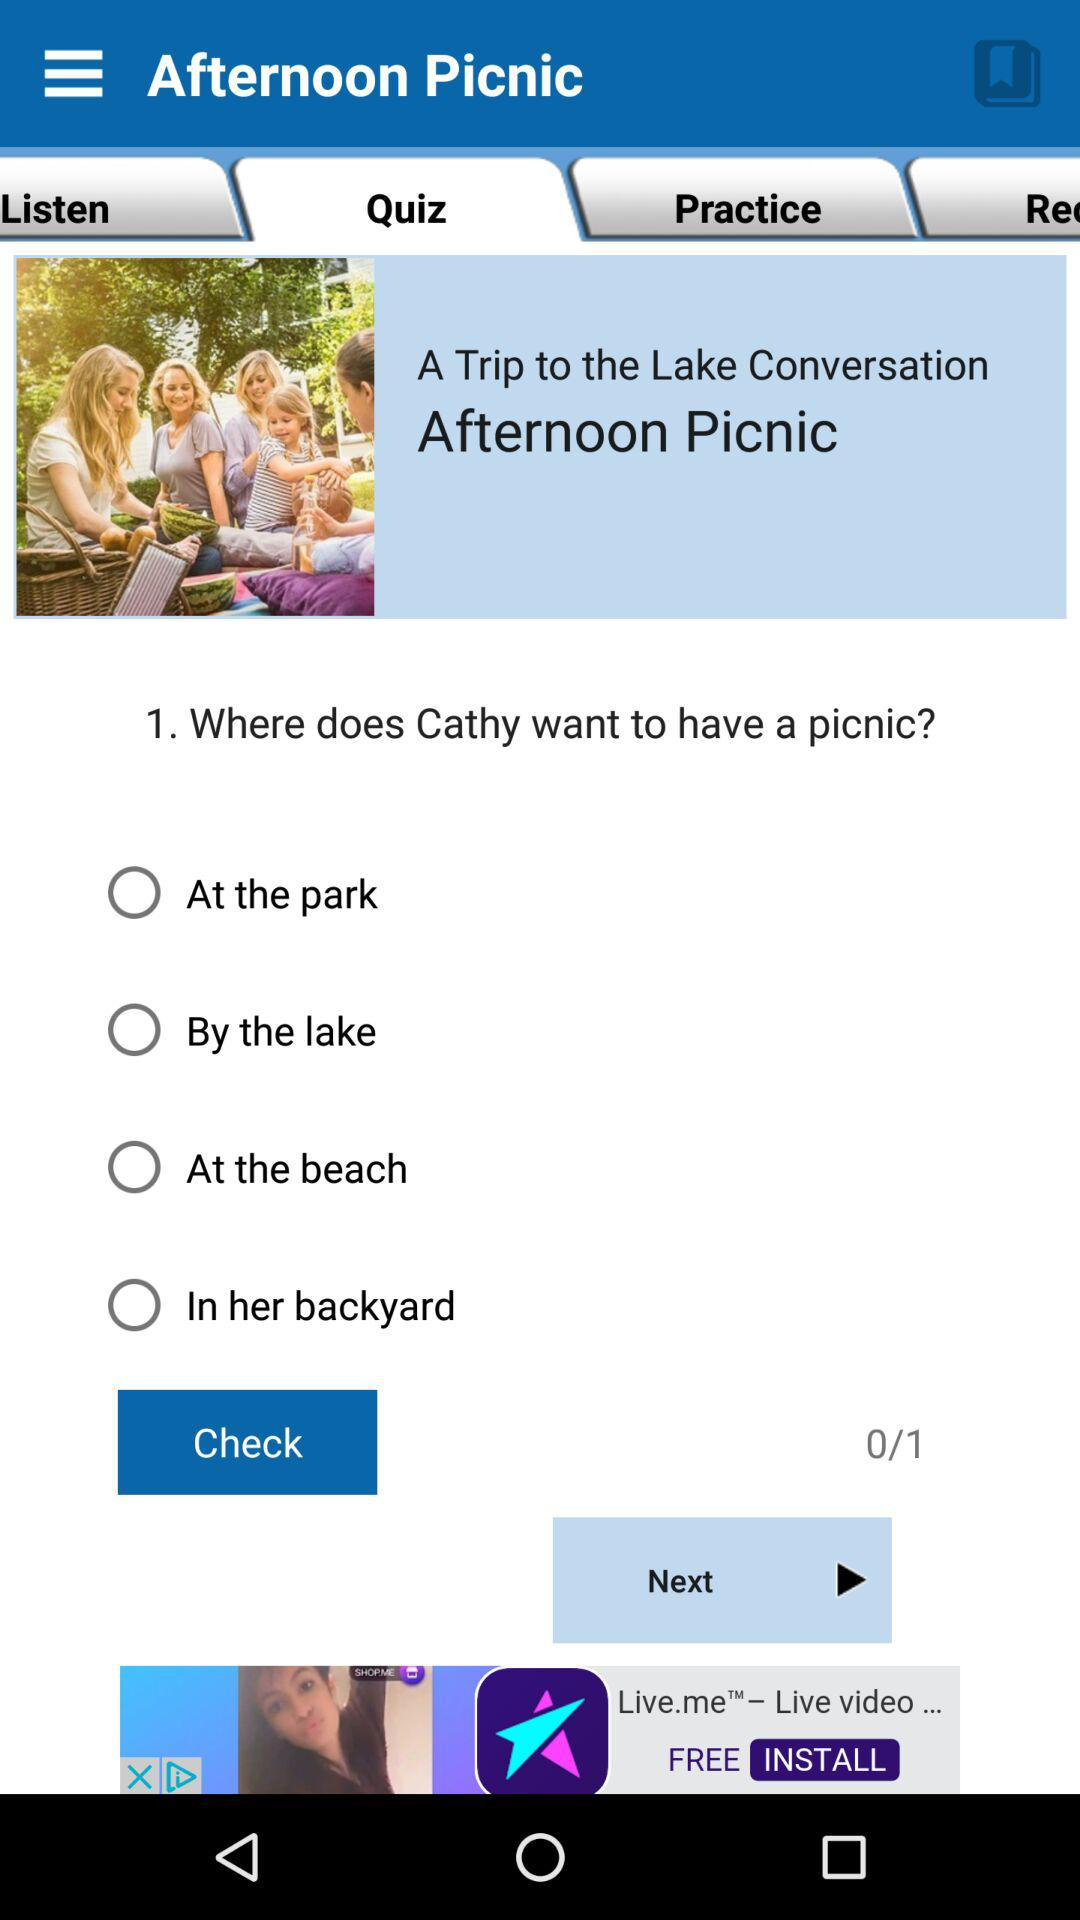How many options are there for where Cathy wants to have a picnic?
Answer the question using a single word or phrase. 4 